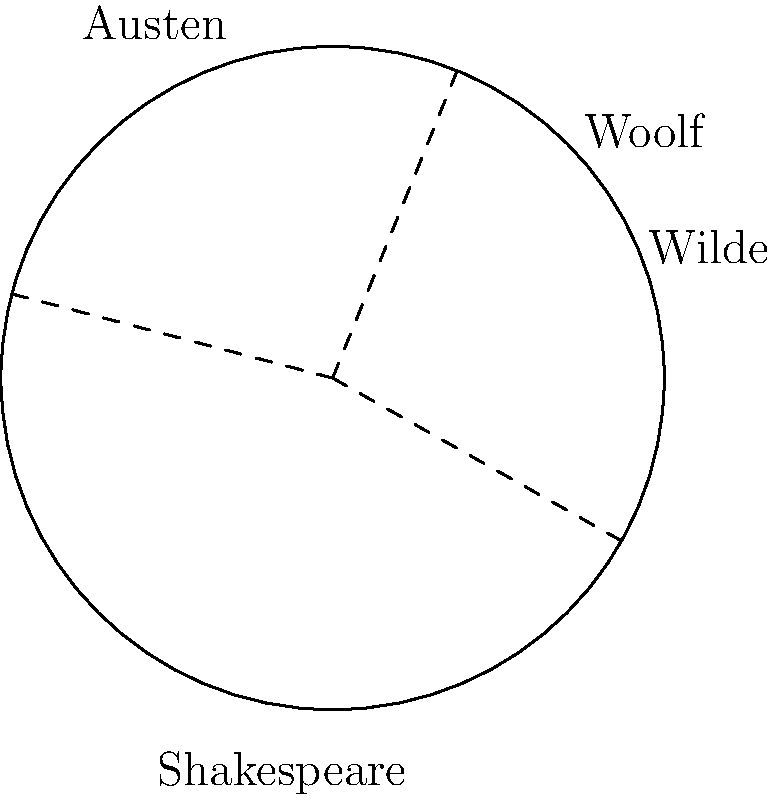In a circular garden dedicated to classic authors, different sectors represent works by Shakespeare, Austen, Wilde, and Woolf. The garden has a radius of 10 meters. If Shakespeare's sector occupies 20% of the total area, Austen's 30%, and Wilde's 25%, what is the area (in square meters) of the sector dedicated to Virginia Woolf's works? Round your answer to two decimal places. Let's approach this step-by-step:

1) First, we need to calculate the total area of the circular garden:
   $A_{total} = \pi r^2 = \pi (10)^2 = 100\pi$ square meters

2) Now, let's calculate the percentage of the garden dedicated to Woolf:
   Shakespeare: 20%
   Austen: 30%
   Wilde: 25%
   Total of these three: 75%
   
   Therefore, Woolf's sector: 100% - 75% = 25%

3) To find the area of Woolf's sector, we calculate 25% of the total area:
   $A_{Woolf} = 25\% \times 100\pi = 0.25 \times 100\pi = 25\pi$ square meters

4) Converting to a numerical value and rounding to two decimal places:
   $25\pi \approx 78.54$ square meters
Answer: 78.54 square meters 